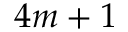Convert formula to latex. <formula><loc_0><loc_0><loc_500><loc_500>4 m + 1</formula> 